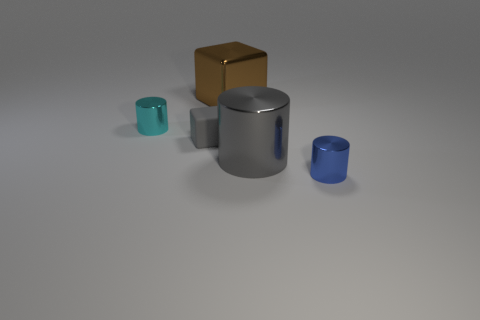Add 3 tiny matte objects. How many objects exist? 8 Subtract all cubes. How many objects are left? 3 Subtract all gray cubes. Subtract all brown metal objects. How many objects are left? 3 Add 4 tiny blue cylinders. How many tiny blue cylinders are left? 5 Add 3 tiny gray rubber blocks. How many tiny gray rubber blocks exist? 4 Subtract 0 brown cylinders. How many objects are left? 5 